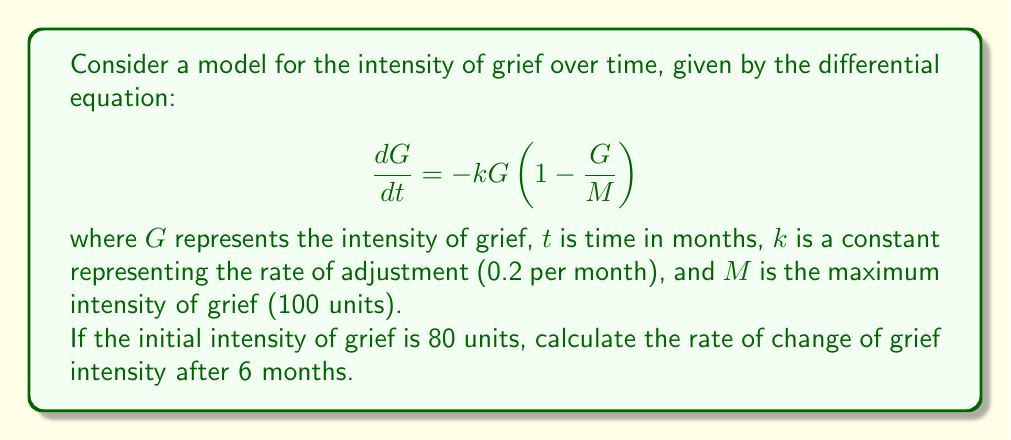Provide a solution to this math problem. 1) We start with the given differential equation:
   $$\frac{dG}{dt} = -kG(1-\frac{G}{M})$$

2) We're given that $k = 0.2$, $M = 100$, and the initial $G = 80$.

3) To find $G$ at 6 months, we need to solve this differential equation. The solution is:
   $$G(t) = \frac{M}{1 + (\frac{M}{G_0} - 1)e^{kt}}$$

   where $G_0$ is the initial grief intensity.

4) Substituting our values:
   $$G(t) = \frac{100}{1 + (\frac{100}{80} - 1)e^{0.2t}}$$

5) At $t = 6$ months:
   $$G(6) = \frac{100}{1 + (\frac{100}{80} - 1)e^{0.2(6)}} \approx 58.21$$

6) Now that we have $G(6)$, we can substitute this back into our original differential equation to find the rate of change at 6 months:

   $$\frac{dG}{dt} = -0.2(58.21)(1-\frac{58.21}{100})$$

7) Calculating:
   $$\frac{dG}{dt} = -0.2(58.21)(0.4179) \approx -4.87$$
Answer: $-4.87$ units per month 